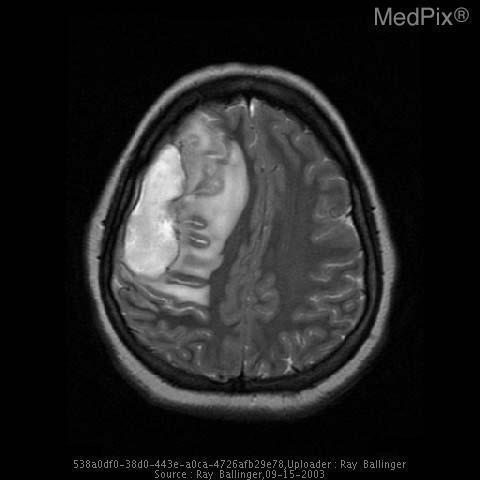The increased signal is a result of what material?
Give a very brief answer. Fluid. Mri imaging modality used for this image?
Concise answer only. T2 weighted. What type of mri is used to acquire this image?
Quick response, please. T2 weighted. Does this image show edema?
Concise answer only. Yes. Is there edema?
Quick response, please. Yes. Does the image show midline shift?
Concise answer only. Yes. Is there midline shift?
Answer briefly. Yes. 